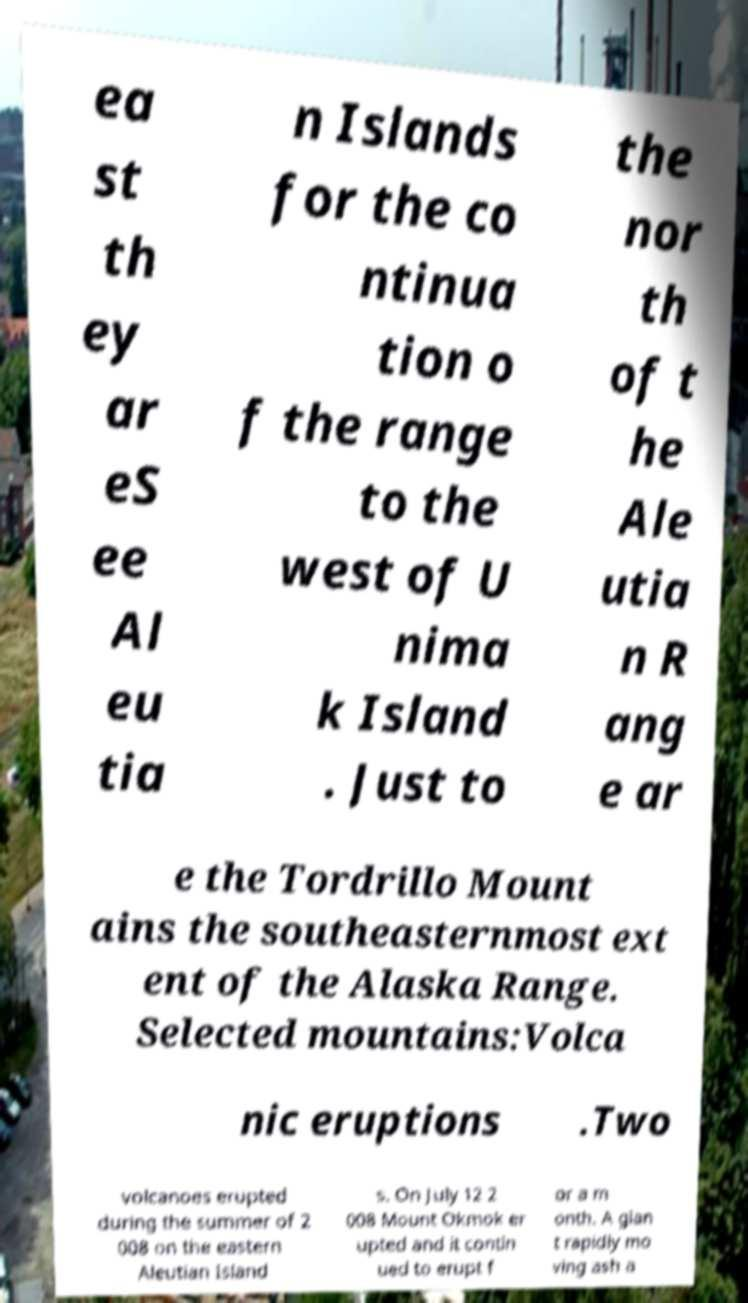What messages or text are displayed in this image? I need them in a readable, typed format. ea st th ey ar eS ee Al eu tia n Islands for the co ntinua tion o f the range to the west of U nima k Island . Just to the nor th of t he Ale utia n R ang e ar e the Tordrillo Mount ains the southeasternmost ext ent of the Alaska Range. Selected mountains:Volca nic eruptions .Two volcanoes erupted during the summer of 2 008 on the eastern Aleutian Island s. On July 12 2 008 Mount Okmok er upted and it contin ued to erupt f or a m onth. A gian t rapidly mo ving ash a 